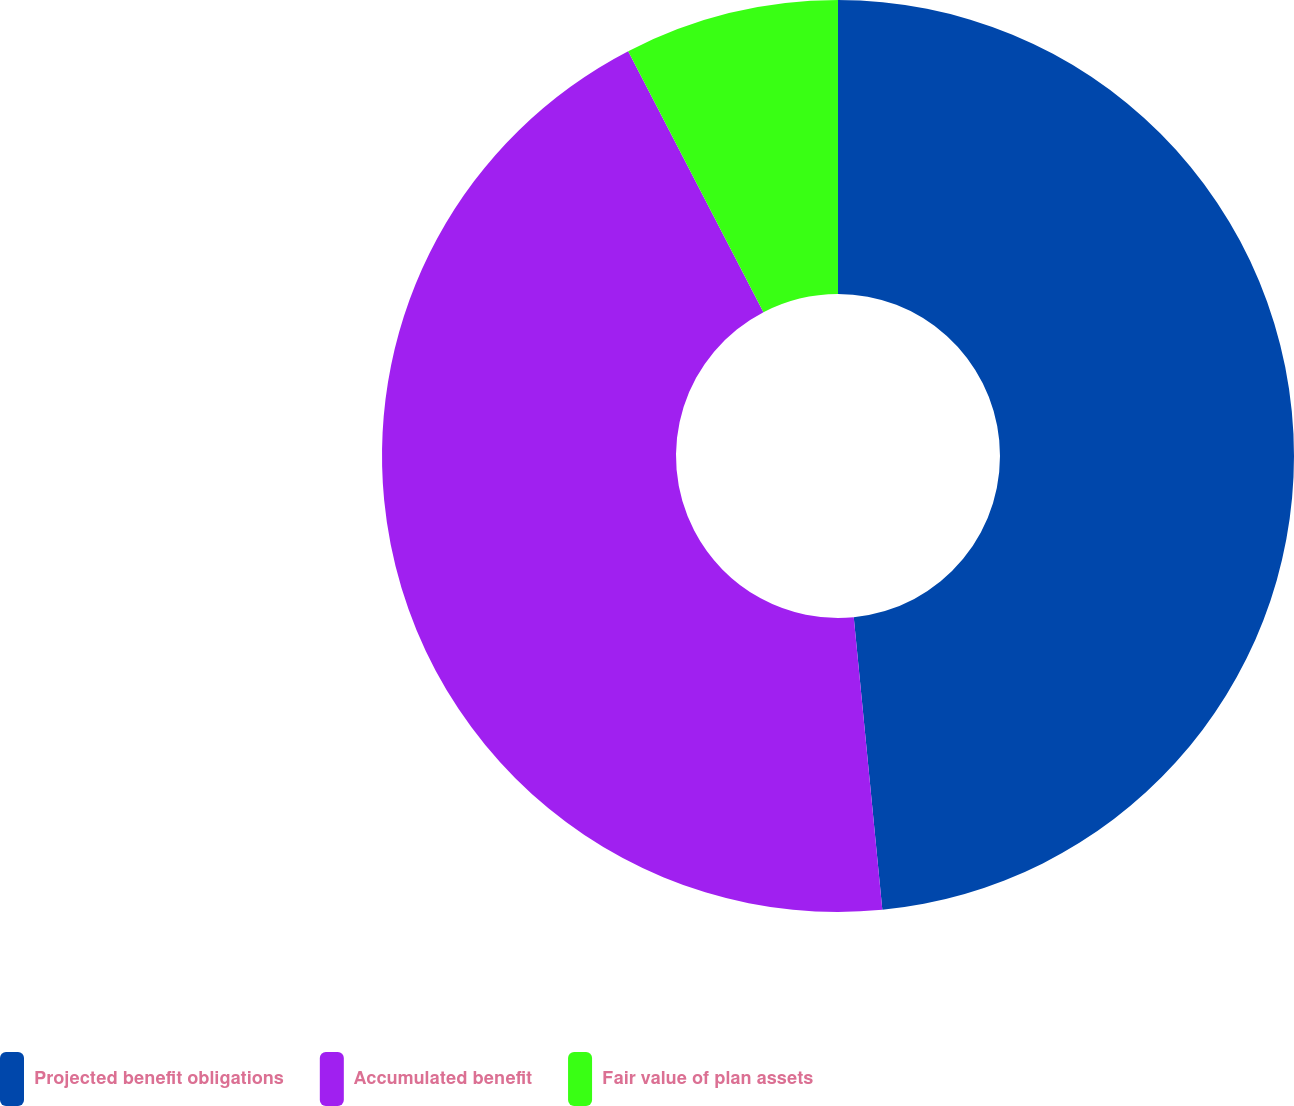Convert chart. <chart><loc_0><loc_0><loc_500><loc_500><pie_chart><fcel>Projected benefit obligations<fcel>Accumulated benefit<fcel>Fair value of plan assets<nl><fcel>48.45%<fcel>43.94%<fcel>7.61%<nl></chart> 